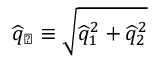<formula> <loc_0><loc_0><loc_500><loc_500>\widehat { q } _ { \perp } \equiv \sqrt { \widehat { q } _ { 1 } ^ { 2 } + \widehat { q } _ { 2 } ^ { 2 } }</formula> 